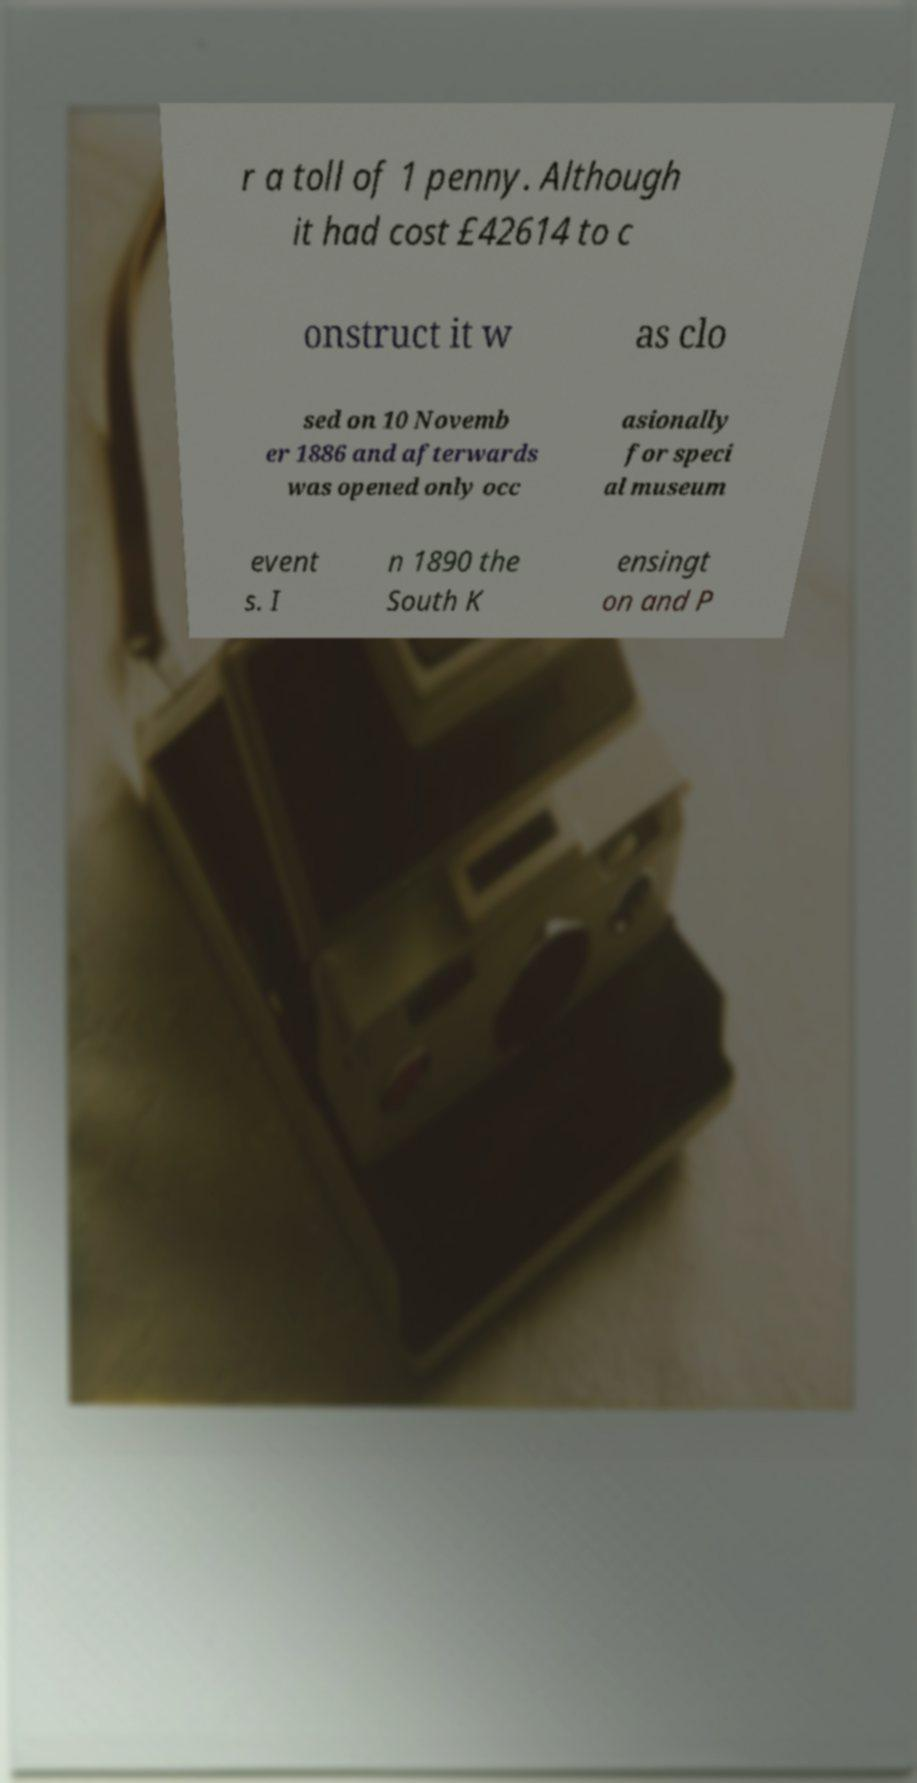There's text embedded in this image that I need extracted. Can you transcribe it verbatim? r a toll of 1 penny. Although it had cost £42614 to c onstruct it w as clo sed on 10 Novemb er 1886 and afterwards was opened only occ asionally for speci al museum event s. I n 1890 the South K ensingt on and P 